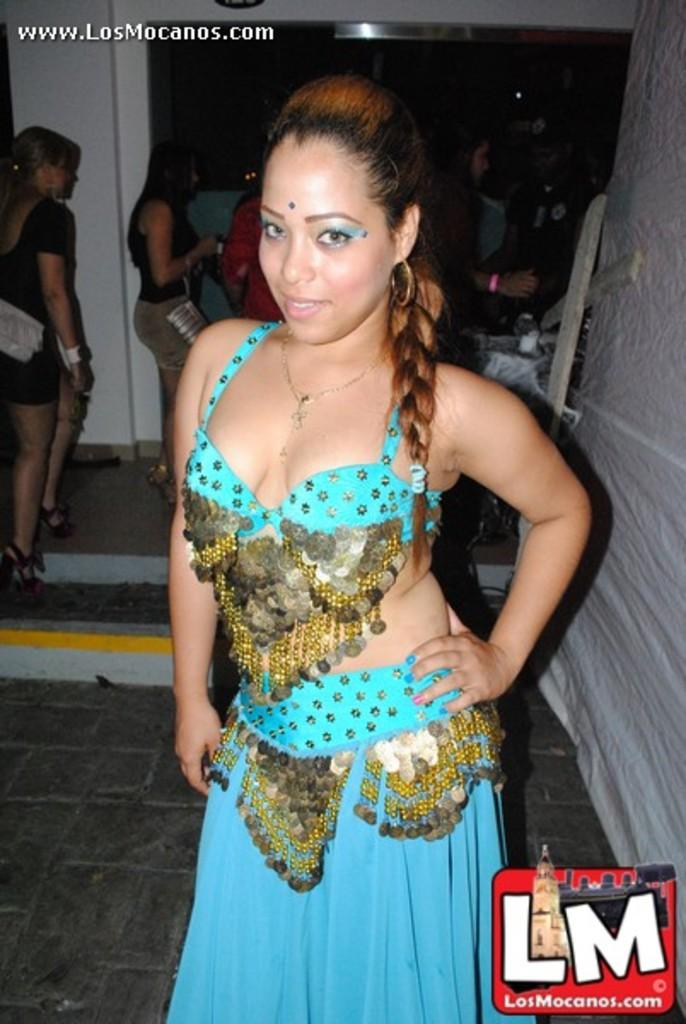What can be seen in the image regarding the people? There are persons wearing clothes in the image. Is there any text or symbol in the image? Yes, there is a logo in the bottom right of the image. What objects are on the right side of the image? There are wooden sticks on the right side of the image. What type of disease is depicted in the image? There is no disease depicted in the image; it features persons wearing clothes and a logo. Can you tell me how many airplanes are visible in the image? There are no airplanes present in the image. 